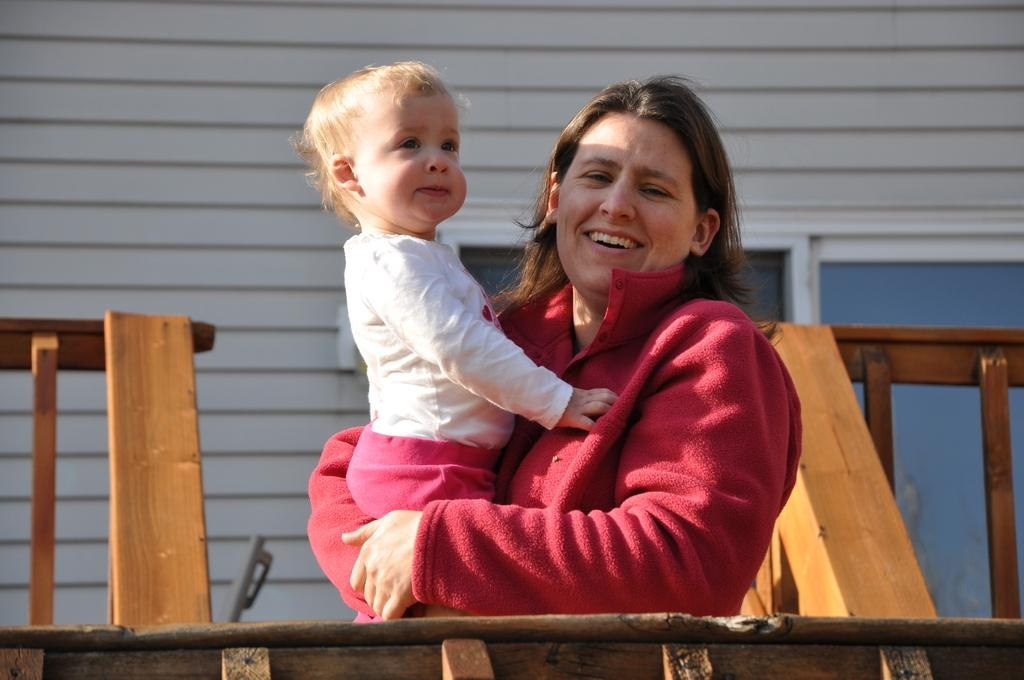What is the person in the image wearing? The person in the image is wearing a red sweatshirt. What is the person holding in the image? The person is holding a baby in a white dress. What can be seen in the background of the image? There is a building with windows in the background. What type of fence is present on either side of the image? There is a wooden fence on either side of the image. What type of food is the person feeding the baby in the image? There is no food present in the image; the person is holding a baby in a white dress. Can you describe the kiss between the person and the baby in the image? There is no kiss depicted in the image; the person is simply holding the baby. 